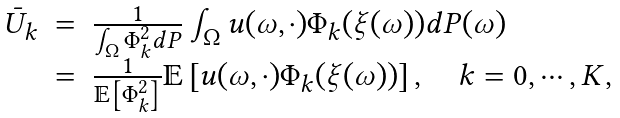<formula> <loc_0><loc_0><loc_500><loc_500>\begin{array} { r c l } \bar { U } _ { k } & = & \frac { 1 } { \int _ { \Omega } \Phi _ { k } ^ { 2 } d P } \int _ { \Omega } u ( \omega , \cdot ) \Phi _ { k } ( \xi ( \omega ) ) d P ( \omega ) \\ & = & \frac { 1 } { \mathbb { E } \left [ \Phi _ { k } ^ { 2 } \right ] } \mathbb { E } \left [ u ( \omega , \cdot ) \Phi _ { k } ( \xi ( \omega ) ) \right ] , \quad k = 0 , \cdots , K , \end{array}</formula> 